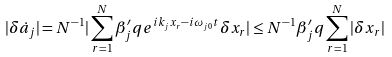<formula> <loc_0><loc_0><loc_500><loc_500>| \delta \dot { a } _ { j } | = N ^ { - 1 } | \sum _ { r = 1 } ^ { N } \beta _ { j } ^ { \prime } q e ^ { i k _ { j } x _ { r } - i \omega _ { j 0 } t } \delta x _ { r } | \leq N ^ { - 1 } \beta _ { j } ^ { \prime } q \sum _ { r = 1 } ^ { N } | \delta x _ { r } |</formula> 